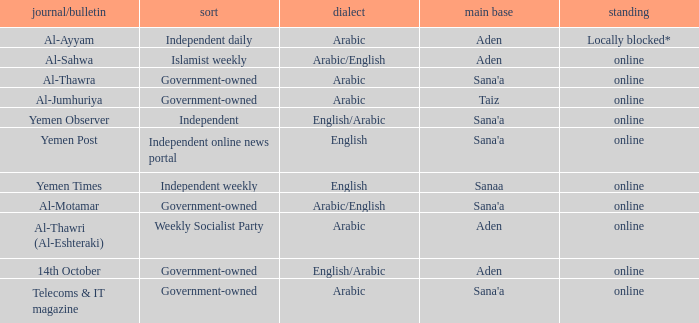What is Type, when Newspaper/Magazine is Telecoms & It Magazine? Government-owned. 